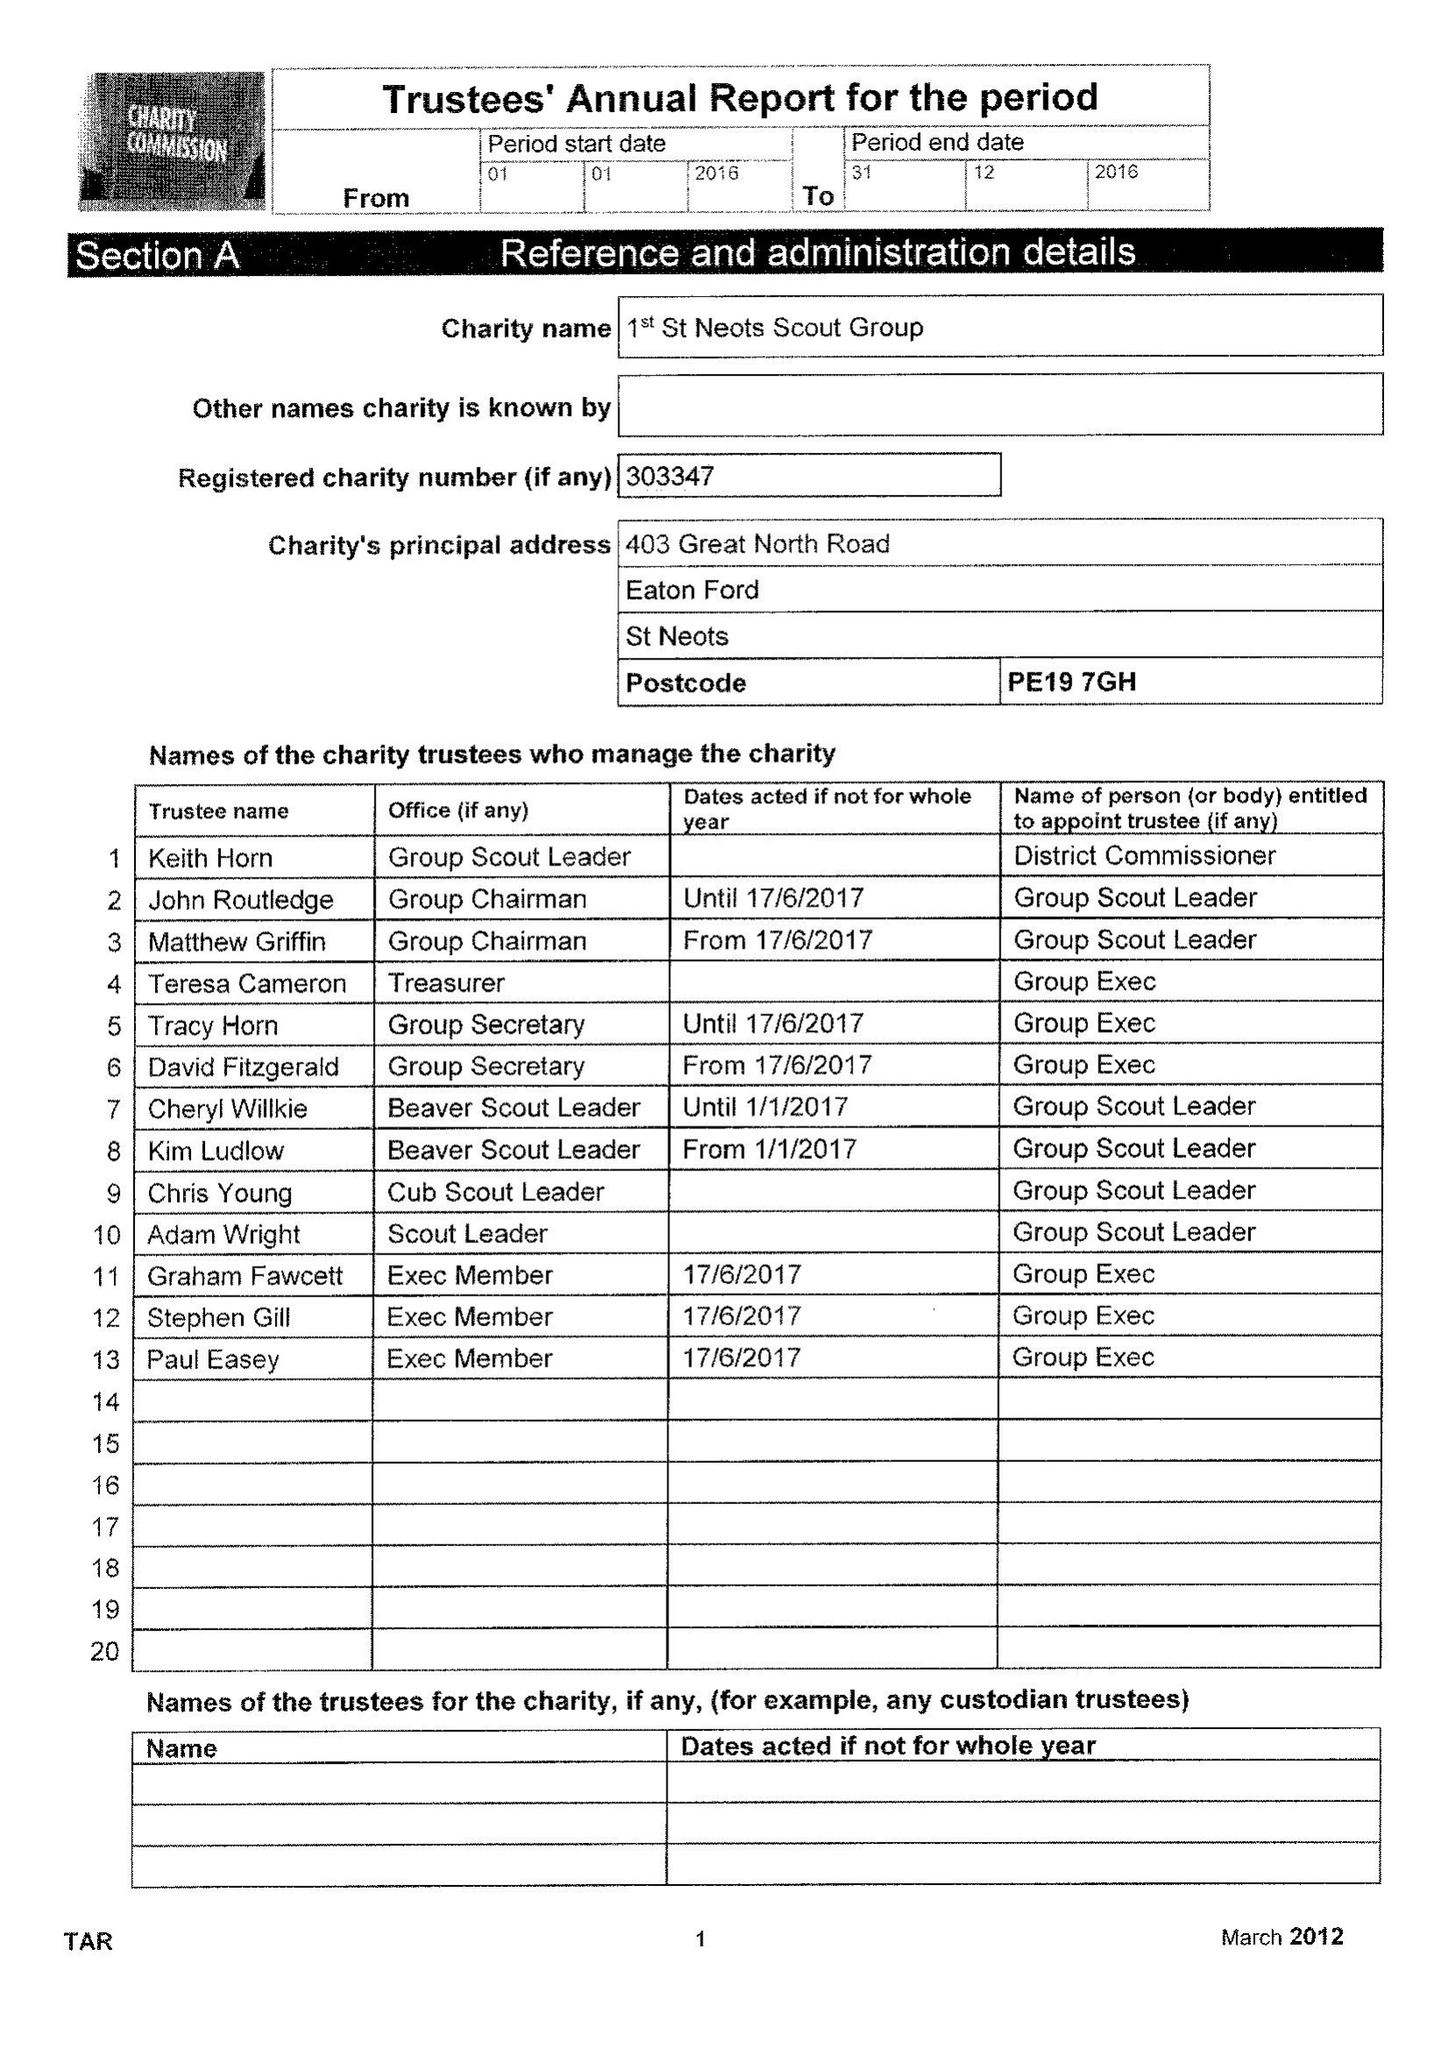What is the value for the spending_annually_in_british_pounds?
Answer the question using a single word or phrase. 116630.00 